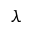<formula> <loc_0><loc_0><loc_500><loc_500>\lambda</formula> 